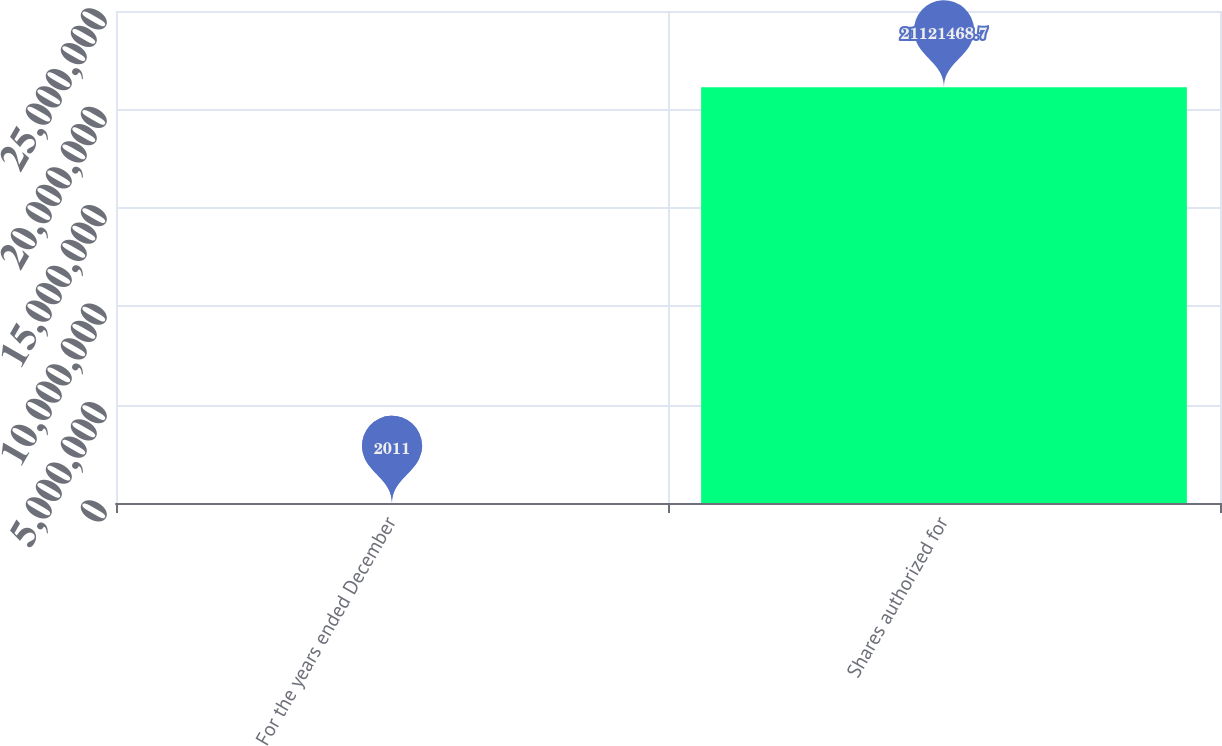Convert chart to OTSL. <chart><loc_0><loc_0><loc_500><loc_500><bar_chart><fcel>For the years ended December<fcel>Shares authorized for<nl><fcel>2011<fcel>2.11215e+07<nl></chart> 